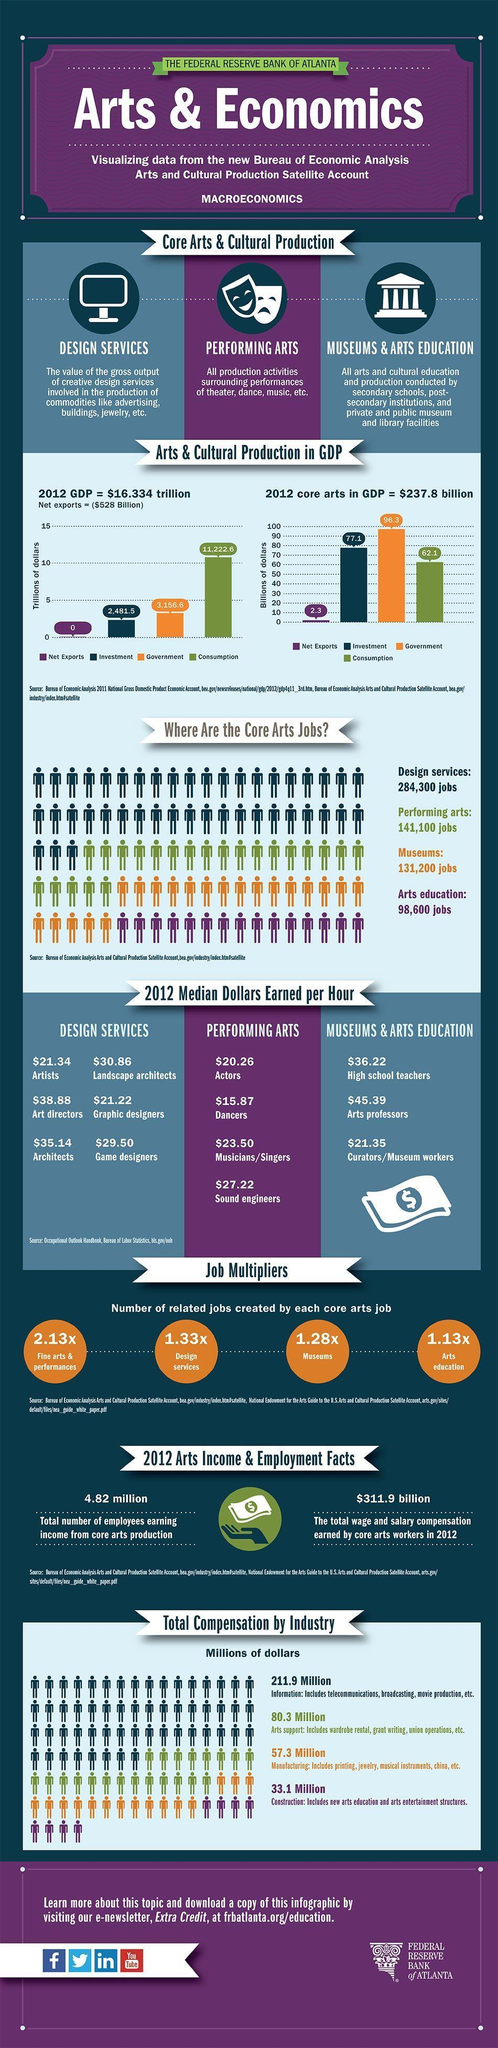which area is core art job opportunities more
Answer the question with a short phrase. design services what has been the wage and salary compensation earned by core arts workers in 2012 $311.9 billion how much do graphic designers earn per hour $21.22 how many employees are earning from core arts production 4.82 million which category do dancers come in performing arts what is the dollars earned per hour by arts professors $45.39 what is the difference in the count of jobs availability in design services and performing arts 143200 